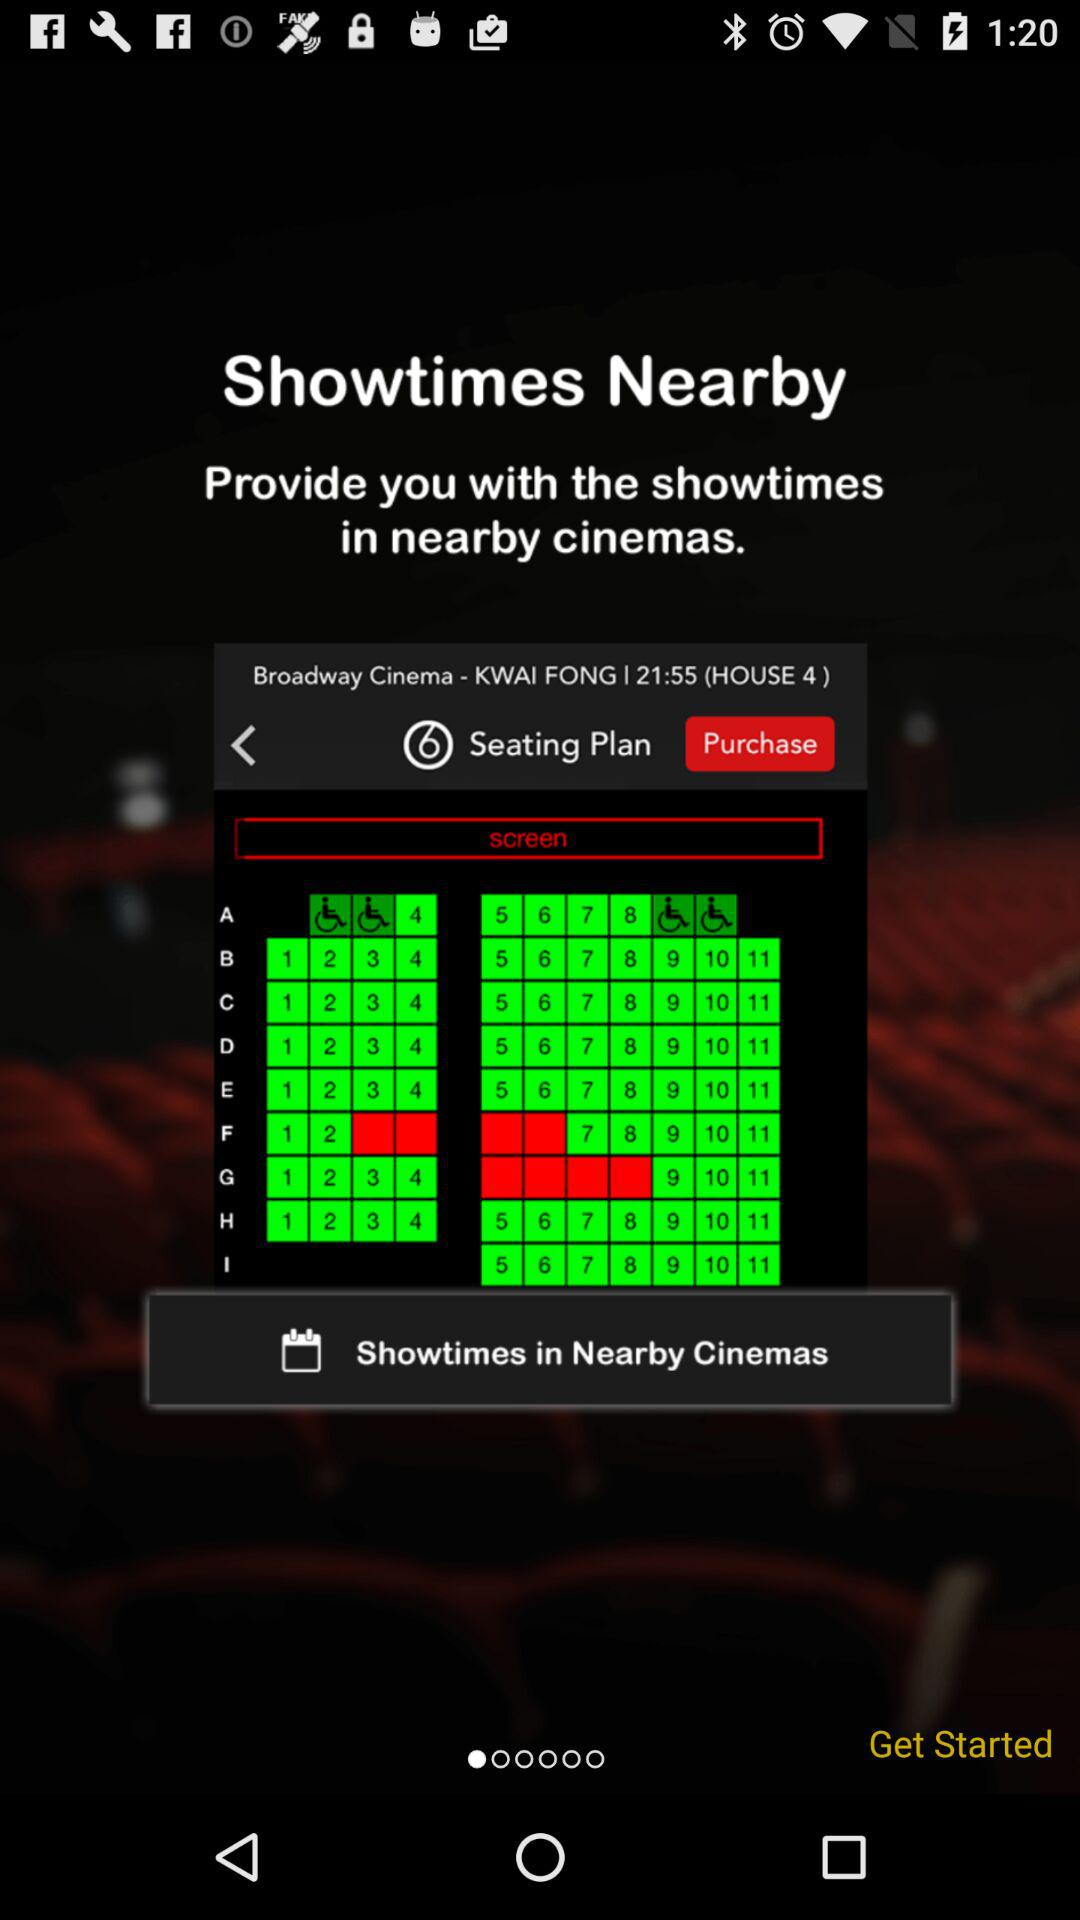What is the theatre's name? The theatre's name is "Broadway Cinema". 